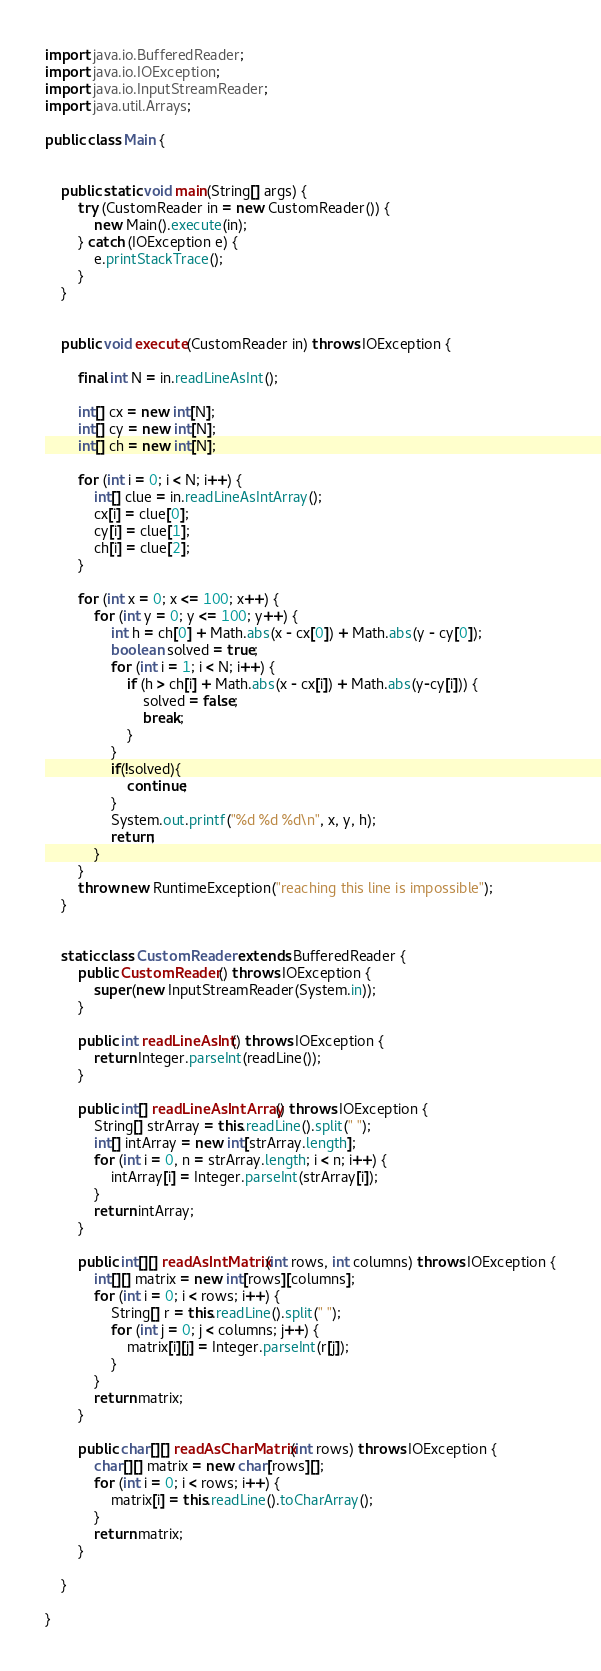Convert code to text. <code><loc_0><loc_0><loc_500><loc_500><_Java_>import java.io.BufferedReader;
import java.io.IOException;
import java.io.InputStreamReader;
import java.util.Arrays;

public class Main {


    public static void main(String[] args) {
        try (CustomReader in = new CustomReader()) {
            new Main().execute(in);
        } catch (IOException e) {
            e.printStackTrace();
        }
    }


    public void execute(CustomReader in) throws IOException {

        final int N = in.readLineAsInt();

        int[] cx = new int[N];
        int[] cy = new int[N];
        int[] ch = new int[N];

        for (int i = 0; i < N; i++) {
            int[] clue = in.readLineAsIntArray();
            cx[i] = clue[0];
            cy[i] = clue[1];
            ch[i] = clue[2];
        }

        for (int x = 0; x <= 100; x++) {
            for (int y = 0; y <= 100; y++) {
                int h = ch[0] + Math.abs(x - cx[0]) + Math.abs(y - cy[0]);
                boolean solved = true;
                for (int i = 1; i < N; i++) {
                    if (h > ch[i] + Math.abs(x - cx[i]) + Math.abs(y-cy[i])) {
                        solved = false;
                        break;
                    }
                }
                if(!solved){
                    continue;
                }
                System.out.printf("%d %d %d\n", x, y, h);
                return;
            }
        }
        throw new RuntimeException("reaching this line is impossible");
    }


    static class CustomReader extends BufferedReader {
        public CustomReader() throws IOException {
            super(new InputStreamReader(System.in));
        }

        public int readLineAsInt() throws IOException {
            return Integer.parseInt(readLine());
        }

        public int[] readLineAsIntArray() throws IOException {
            String[] strArray = this.readLine().split(" ");
            int[] intArray = new int[strArray.length];
            for (int i = 0, n = strArray.length; i < n; i++) {
                intArray[i] = Integer.parseInt(strArray[i]);
            }
            return intArray;
        }

        public int[][] readAsIntMatrix(int rows, int columns) throws IOException {
            int[][] matrix = new int[rows][columns];
            for (int i = 0; i < rows; i++) {
                String[] r = this.readLine().split(" ");
                for (int j = 0; j < columns; j++) {
                    matrix[i][j] = Integer.parseInt(r[j]);
                }
            }
            return matrix;
        }

        public char[][] readAsCharMatrix(int rows) throws IOException {
            char[][] matrix = new char[rows][];
            for (int i = 0; i < rows; i++) {
                matrix[i] = this.readLine().toCharArray();
            }
            return matrix;
        }

    }

}</code> 